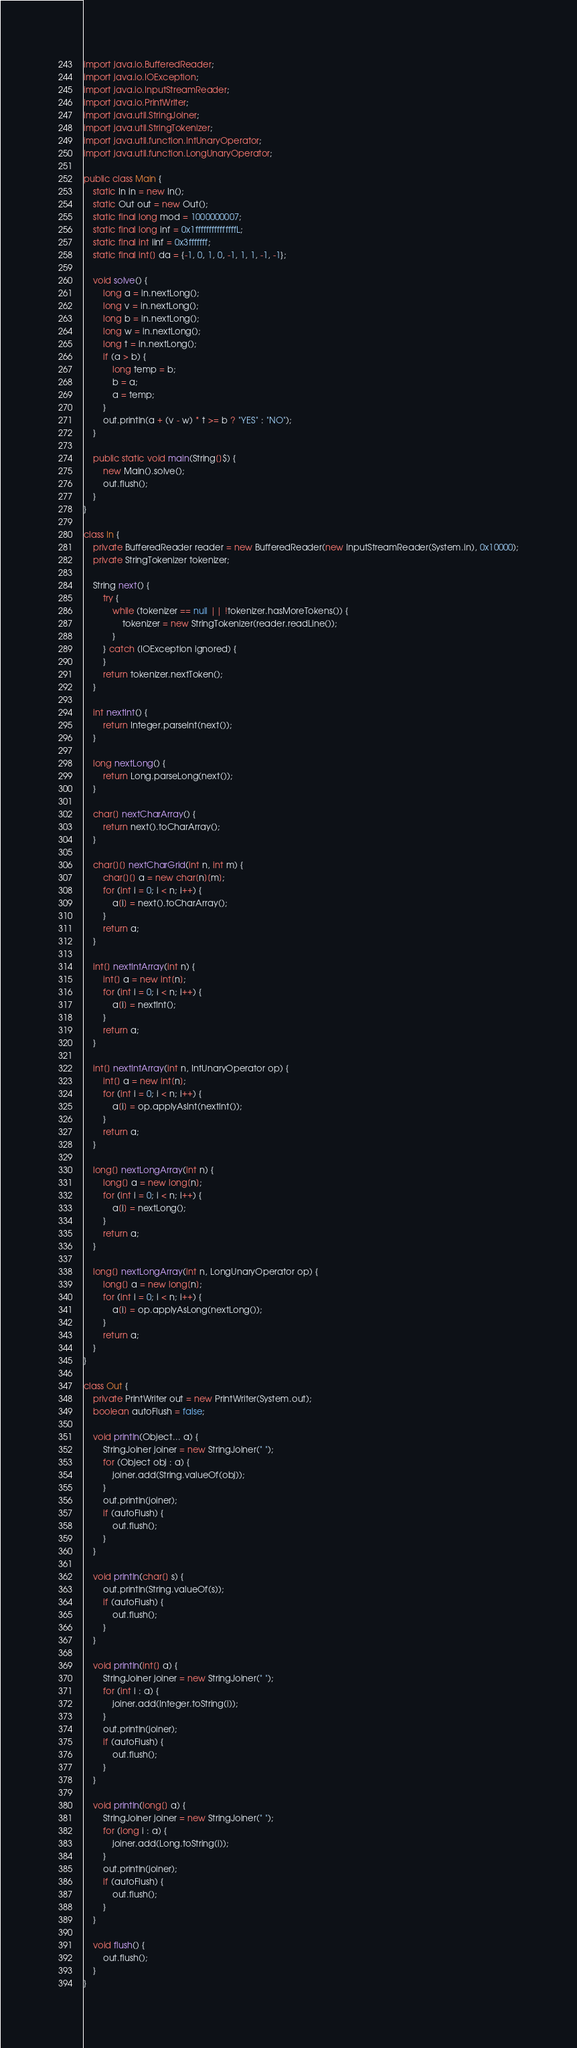<code> <loc_0><loc_0><loc_500><loc_500><_Java_>import java.io.BufferedReader;
import java.io.IOException;
import java.io.InputStreamReader;
import java.io.PrintWriter;
import java.util.StringJoiner;
import java.util.StringTokenizer;
import java.util.function.IntUnaryOperator;
import java.util.function.LongUnaryOperator;

public class Main {
    static In in = new In();
    static Out out = new Out();
    static final long mod = 1000000007;
    static final long inf = 0x1fffffffffffffffL;
    static final int iinf = 0x3fffffff;
    static final int[] da = {-1, 0, 1, 0, -1, 1, 1, -1, -1};

    void solve() {
        long a = in.nextLong();
        long v = in.nextLong();
        long b = in.nextLong();
        long w = in.nextLong();
        long t = in.nextLong();
        if (a > b) {
            long temp = b;
            b = a;
            a = temp;
        }
        out.println(a + (v - w) * t >= b ? "YES" : "NO");
    }

    public static void main(String[]$) {
        new Main().solve();
        out.flush();
    }
}

class In {
    private BufferedReader reader = new BufferedReader(new InputStreamReader(System.in), 0x10000);
    private StringTokenizer tokenizer;

    String next() {
        try {
            while (tokenizer == null || !tokenizer.hasMoreTokens()) {
                tokenizer = new StringTokenizer(reader.readLine());
            }
        } catch (IOException ignored) {
        }
        return tokenizer.nextToken();
    }

    int nextInt() {
        return Integer.parseInt(next());
    }

    long nextLong() {
        return Long.parseLong(next());
    }

    char[] nextCharArray() {
        return next().toCharArray();
    }

    char[][] nextCharGrid(int n, int m) {
        char[][] a = new char[n][m];
        for (int i = 0; i < n; i++) {
            a[i] = next().toCharArray();
        }
        return a;
    }

    int[] nextIntArray(int n) {
        int[] a = new int[n];
        for (int i = 0; i < n; i++) {
            a[i] = nextInt();
        }
        return a;
    }

    int[] nextIntArray(int n, IntUnaryOperator op) {
        int[] a = new int[n];
        for (int i = 0; i < n; i++) {
            a[i] = op.applyAsInt(nextInt());
        }
        return a;
    }

    long[] nextLongArray(int n) {
        long[] a = new long[n];
        for (int i = 0; i < n; i++) {
            a[i] = nextLong();
        }
        return a;
    }

    long[] nextLongArray(int n, LongUnaryOperator op) {
        long[] a = new long[n];
        for (int i = 0; i < n; i++) {
            a[i] = op.applyAsLong(nextLong());
        }
        return a;
    }
}

class Out {
    private PrintWriter out = new PrintWriter(System.out);
    boolean autoFlush = false;

    void println(Object... a) {
        StringJoiner joiner = new StringJoiner(" ");
        for (Object obj : a) {
            joiner.add(String.valueOf(obj));
        }
        out.println(joiner);
        if (autoFlush) {
            out.flush();
        }
    }

    void println(char[] s) {
        out.println(String.valueOf(s));
        if (autoFlush) {
            out.flush();
        }
    }

    void println(int[] a) {
        StringJoiner joiner = new StringJoiner(" ");
        for (int i : a) {
            joiner.add(Integer.toString(i));
        }
        out.println(joiner);
        if (autoFlush) {
            out.flush();
        }
    }

    void println(long[] a) {
        StringJoiner joiner = new StringJoiner(" ");
        for (long i : a) {
            joiner.add(Long.toString(i));
        }
        out.println(joiner);
        if (autoFlush) {
            out.flush();
        }
    }

    void flush() {
        out.flush();
    }
}
</code> 